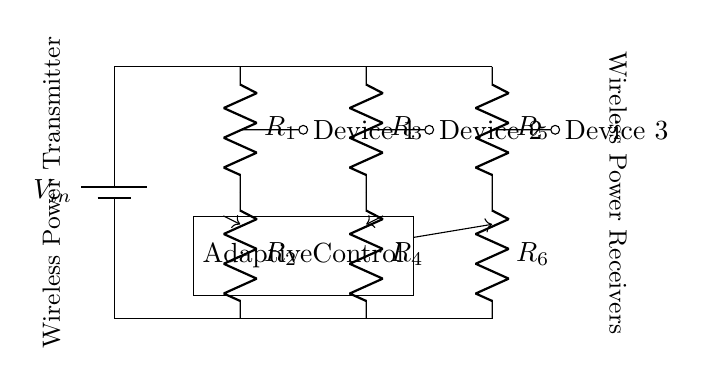What is the input voltage of this circuit? The input voltage is indicated by the battery symbol labeled as V_in on the left side of the circuit diagram. Since the exact numerical value is not specified in the circuit, we refer to it as V_in.
Answer: V_in How many resistors are in the current divider? The circuit has six resistors labeled R1, R2, R3, R4, R5, and R6. They can be counted directly from the components shown in the diagram.
Answer: 6 What is the purpose of the adaptive control in this circuit? The adaptive control unit is positioned below the resistors and is responsible for managing the current distribution to ensure efficient wireless charging among multiple devices. Its function is to optimize the performance based on the connected devices' requirements.
Answer: Current management Which devices are connected to the current divider? The circuit diagram shows three devices connected to the adaptive current divider, labeled as Device 1, Device 2, and Device 3. Each device has a dedicated connection from the resistors, ensuring that they all receive power for charging.
Answer: Device 1, Device 2, Device 3 What is the type of circuit represented? The circuit represents a current divider specifically designed for distributing power among different loads, in this case, multiple devices being charged wirelessly. The arrangement of multiple resistors in parallel indicates it’s a current divider circuit.
Answer: Current divider What is the role of resistors in this circuit? Each resistor in this circuit plays a crucial role in determining how much current flows to each connected device. The resistance values affect the voltage drop across each resistor and therefore influence the current distribution according to Ohm's law.
Answer: Current distribution 